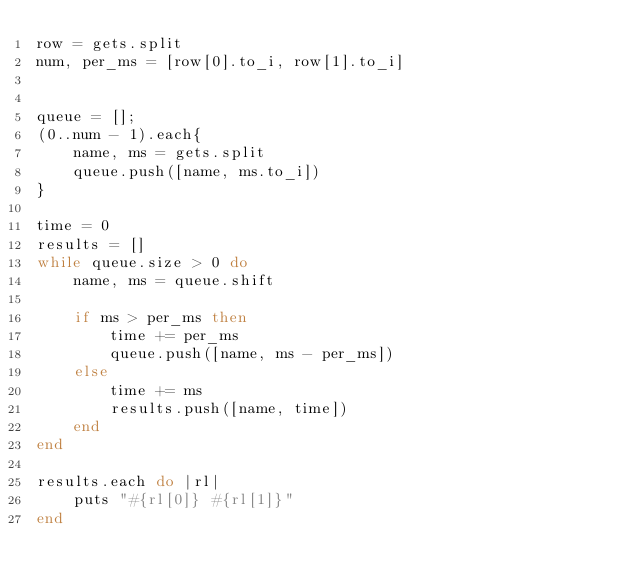<code> <loc_0><loc_0><loc_500><loc_500><_Ruby_>row = gets.split
num, per_ms = [row[0].to_i, row[1].to_i]


queue = [];
(0..num - 1).each{
    name, ms = gets.split
    queue.push([name, ms.to_i])
}

time = 0
results = []
while queue.size > 0 do
    name, ms = queue.shift

    if ms > per_ms then
        time += per_ms
        queue.push([name, ms - per_ms])
    else
        time += ms
        results.push([name, time])
    end
end

results.each do |rl|
    puts "#{rl[0]} #{rl[1]}"
end
</code> 